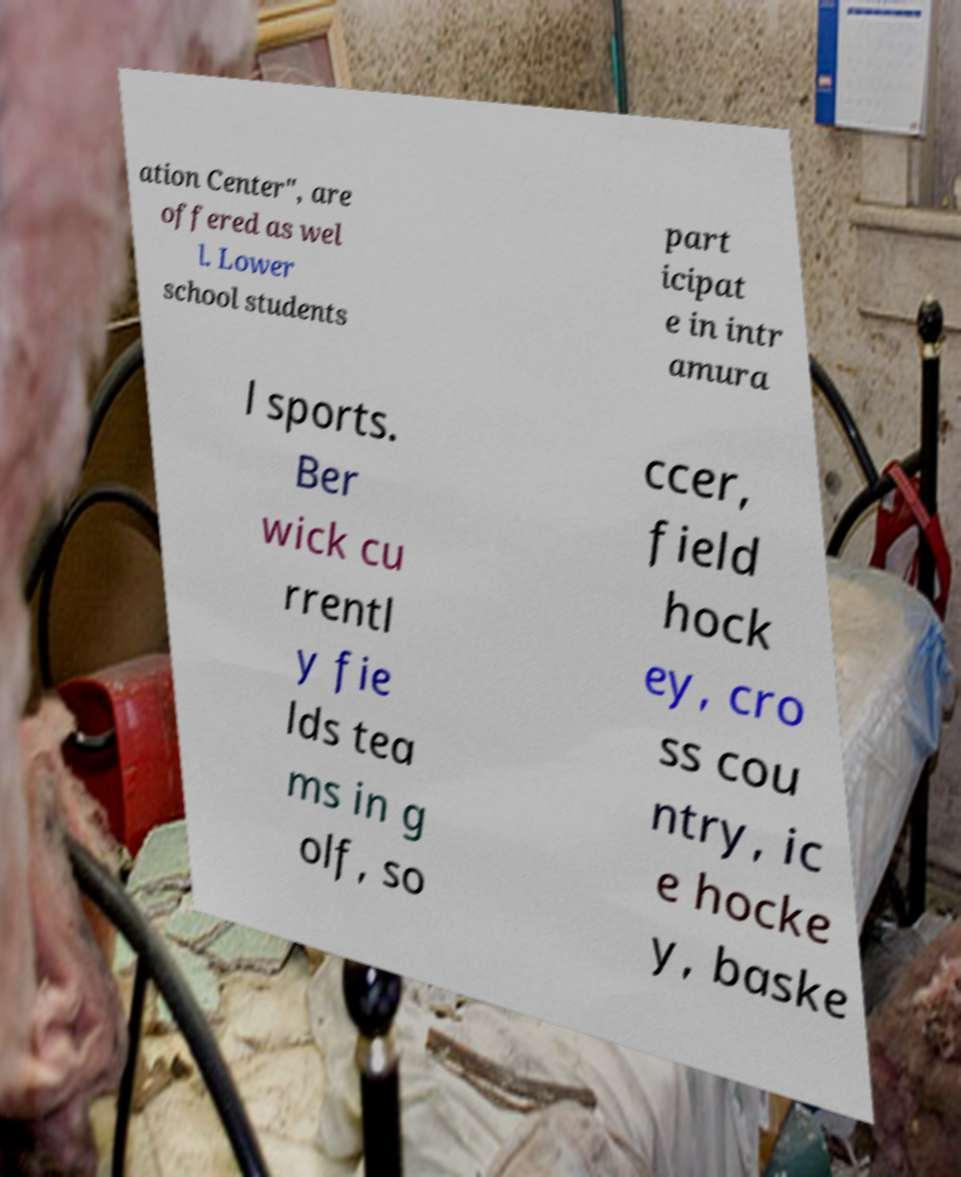I need the written content from this picture converted into text. Can you do that? ation Center", are offered as wel l. Lower school students part icipat e in intr amura l sports. Ber wick cu rrentl y fie lds tea ms in g olf, so ccer, field hock ey, cro ss cou ntry, ic e hocke y, baske 